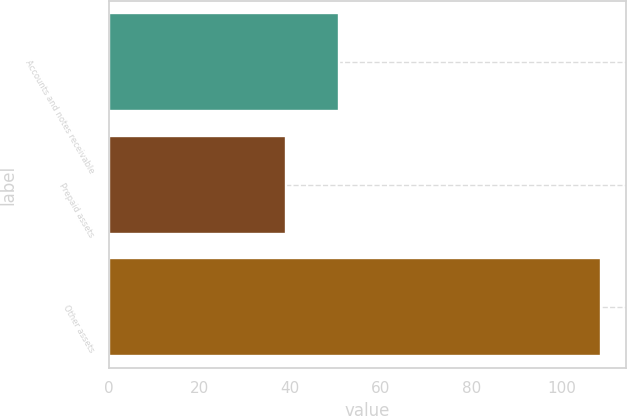Convert chart. <chart><loc_0><loc_0><loc_500><loc_500><bar_chart><fcel>Accounts and notes receivable<fcel>Prepaid assets<fcel>Other assets<nl><fcel>50.7<fcel>39<fcel>108.7<nl></chart> 